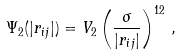Convert formula to latex. <formula><loc_0><loc_0><loc_500><loc_500>\Psi _ { 2 } ( | { r } _ { i j } | ) = V _ { 2 } \left ( \frac { \sigma } { | { r } _ { i j } | } \right ) ^ { 1 2 } \, ,</formula> 